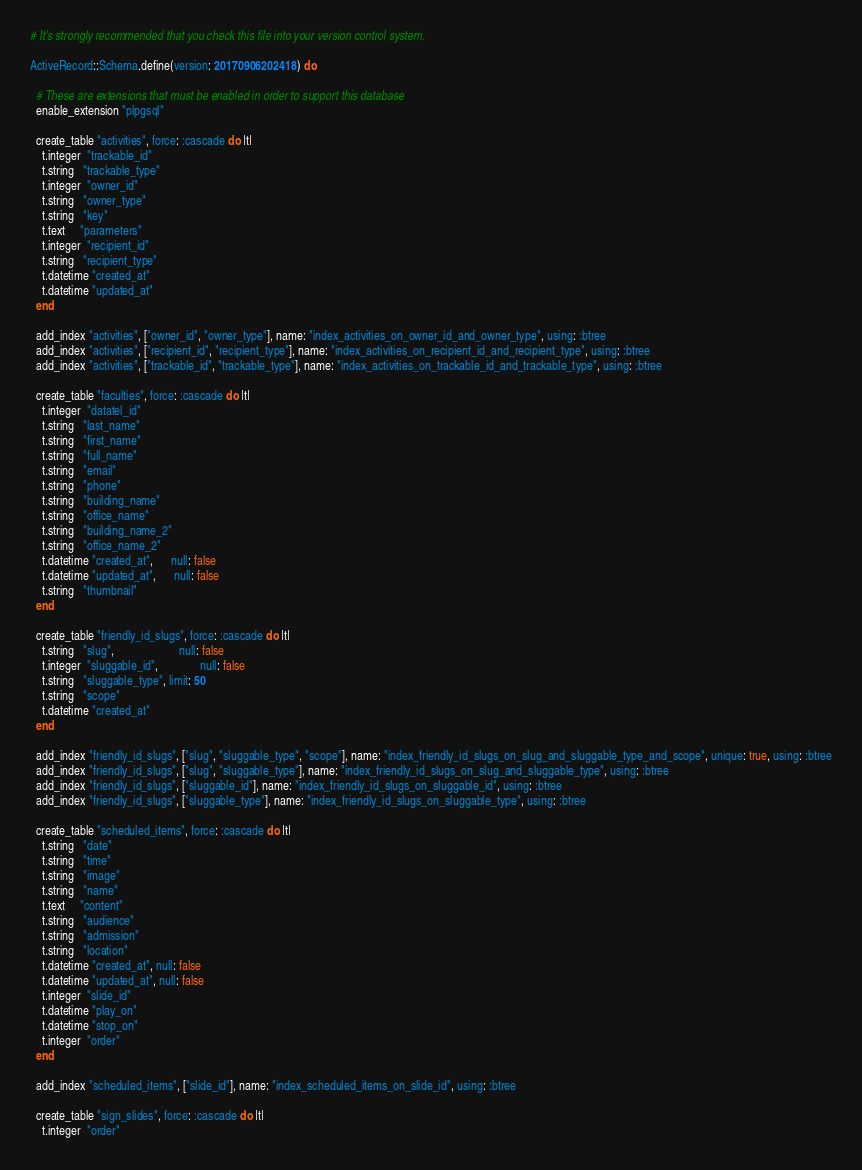Convert code to text. <code><loc_0><loc_0><loc_500><loc_500><_Ruby_># It's strongly recommended that you check this file into your version control system.

ActiveRecord::Schema.define(version: 20170906202418) do

  # These are extensions that must be enabled in order to support this database
  enable_extension "plpgsql"

  create_table "activities", force: :cascade do |t|
    t.integer  "trackable_id"
    t.string   "trackable_type"
    t.integer  "owner_id"
    t.string   "owner_type"
    t.string   "key"
    t.text     "parameters"
    t.integer  "recipient_id"
    t.string   "recipient_type"
    t.datetime "created_at"
    t.datetime "updated_at"
  end

  add_index "activities", ["owner_id", "owner_type"], name: "index_activities_on_owner_id_and_owner_type", using: :btree
  add_index "activities", ["recipient_id", "recipient_type"], name: "index_activities_on_recipient_id_and_recipient_type", using: :btree
  add_index "activities", ["trackable_id", "trackable_type"], name: "index_activities_on_trackable_id_and_trackable_type", using: :btree

  create_table "faculties", force: :cascade do |t|
    t.integer  "datatel_id"
    t.string   "last_name"
    t.string   "first_name"
    t.string   "full_name"
    t.string   "email"
    t.string   "phone"
    t.string   "building_name"
    t.string   "office_name"
    t.string   "building_name_2"
    t.string   "office_name_2"
    t.datetime "created_at",      null: false
    t.datetime "updated_at",      null: false
    t.string   "thumbnail"
  end

  create_table "friendly_id_slugs", force: :cascade do |t|
    t.string   "slug",                      null: false
    t.integer  "sluggable_id",              null: false
    t.string   "sluggable_type", limit: 50
    t.string   "scope"
    t.datetime "created_at"
  end

  add_index "friendly_id_slugs", ["slug", "sluggable_type", "scope"], name: "index_friendly_id_slugs_on_slug_and_sluggable_type_and_scope", unique: true, using: :btree
  add_index "friendly_id_slugs", ["slug", "sluggable_type"], name: "index_friendly_id_slugs_on_slug_and_sluggable_type", using: :btree
  add_index "friendly_id_slugs", ["sluggable_id"], name: "index_friendly_id_slugs_on_sluggable_id", using: :btree
  add_index "friendly_id_slugs", ["sluggable_type"], name: "index_friendly_id_slugs_on_sluggable_type", using: :btree

  create_table "scheduled_items", force: :cascade do |t|
    t.string   "date"
    t.string   "time"
    t.string   "image"
    t.string   "name"
    t.text     "content"
    t.string   "audience"
    t.string   "admission"
    t.string   "location"
    t.datetime "created_at", null: false
    t.datetime "updated_at", null: false
    t.integer  "slide_id"
    t.datetime "play_on"
    t.datetime "stop_on"
    t.integer  "order"
  end

  add_index "scheduled_items", ["slide_id"], name: "index_scheduled_items_on_slide_id", using: :btree

  create_table "sign_slides", force: :cascade do |t|
    t.integer  "order"</code> 